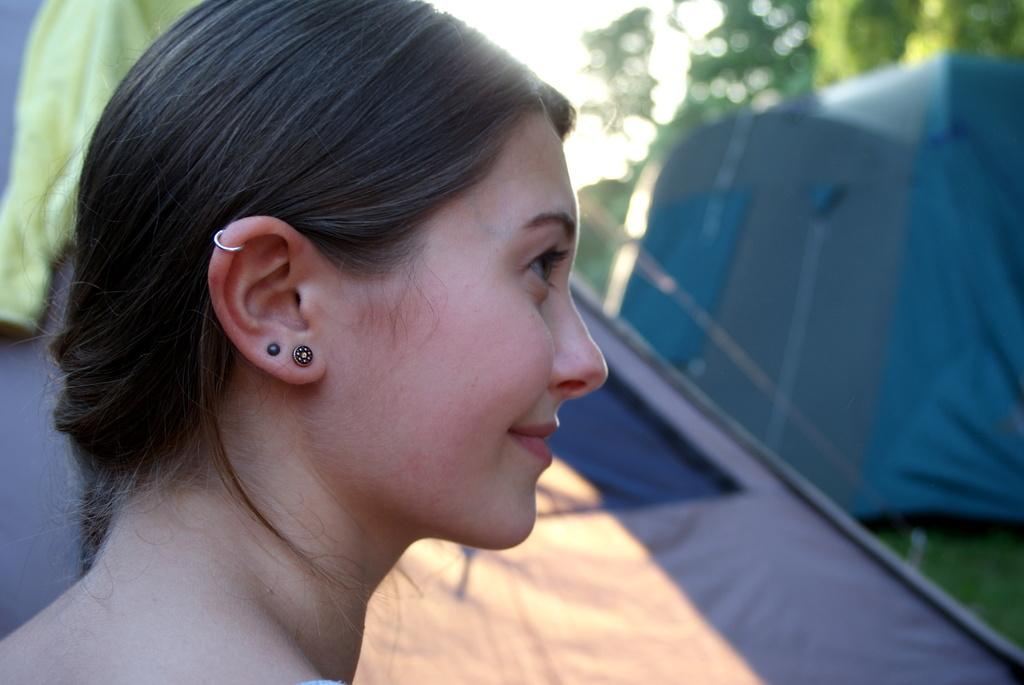Who is present in the image? There is a woman in the image. What is the woman's expression? The woman is smiling. What can be seen in the background of the image? There are tents and grass in the background of the image. How would you describe the background's appearance? The background appears blurry. What type of chain can be seen around the woman's neck in the image? There is no chain visible around the woman's neck in the image. How does the beggar in the image interact with the tents? There is no beggar present in the image; it features a woman smiling with a blurry background of tents and grass. 